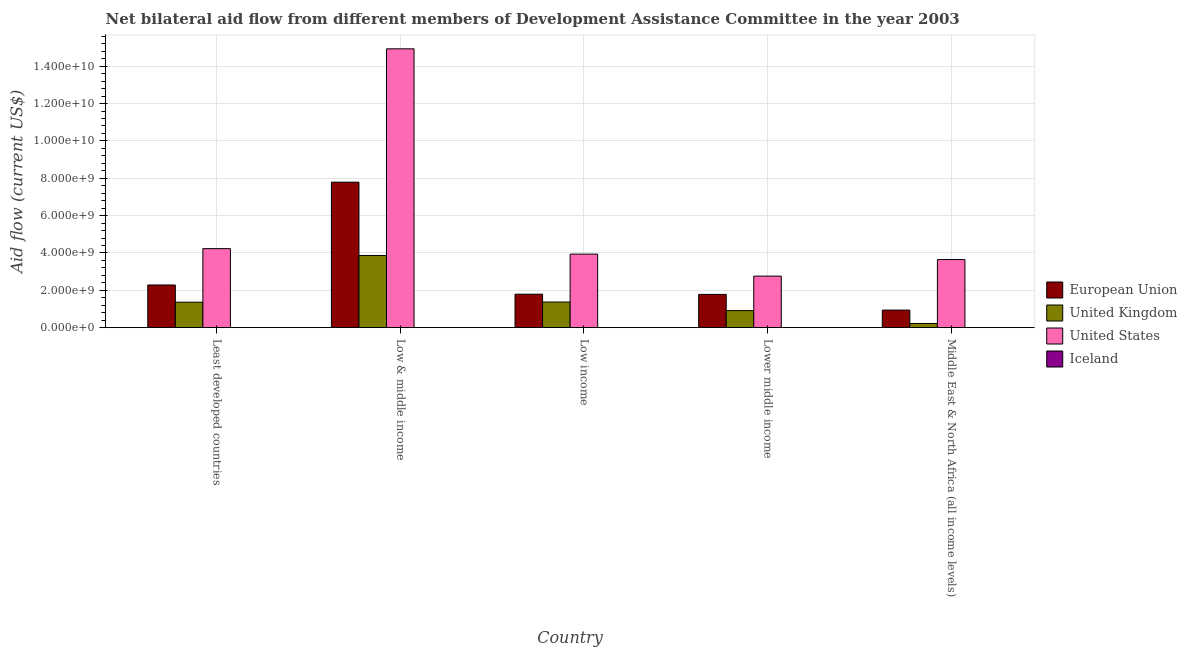How many bars are there on the 2nd tick from the left?
Offer a terse response. 4. What is the label of the 1st group of bars from the left?
Provide a succinct answer. Least developed countries. In how many cases, is the number of bars for a given country not equal to the number of legend labels?
Your answer should be very brief. 0. What is the amount of aid given by iceland in Middle East & North Africa (all income levels)?
Provide a succinct answer. 1.02e+06. Across all countries, what is the maximum amount of aid given by us?
Keep it short and to the point. 1.49e+1. Across all countries, what is the minimum amount of aid given by uk?
Your response must be concise. 2.24e+08. In which country was the amount of aid given by iceland maximum?
Keep it short and to the point. Least developed countries. In which country was the amount of aid given by us minimum?
Offer a terse response. Lower middle income. What is the total amount of aid given by eu in the graph?
Make the answer very short. 1.46e+1. What is the difference between the amount of aid given by iceland in Least developed countries and that in Low & middle income?
Your response must be concise. 6.13e+06. What is the difference between the amount of aid given by uk in Low income and the amount of aid given by eu in Least developed countries?
Keep it short and to the point. -9.13e+08. What is the average amount of aid given by us per country?
Make the answer very short. 5.90e+09. What is the difference between the amount of aid given by us and amount of aid given by uk in Low & middle income?
Offer a terse response. 1.11e+1. In how many countries, is the amount of aid given by iceland greater than 12000000000 US$?
Your answer should be compact. 0. What is the ratio of the amount of aid given by eu in Least developed countries to that in Low income?
Offer a very short reply. 1.28. What is the difference between the highest and the second highest amount of aid given by us?
Offer a terse response. 1.07e+1. What is the difference between the highest and the lowest amount of aid given by uk?
Ensure brevity in your answer.  3.64e+09. Is it the case that in every country, the sum of the amount of aid given by uk and amount of aid given by iceland is greater than the sum of amount of aid given by eu and amount of aid given by us?
Give a very brief answer. No. What does the 1st bar from the left in Least developed countries represents?
Ensure brevity in your answer.  European Union. Are all the bars in the graph horizontal?
Your answer should be compact. No. What is the difference between two consecutive major ticks on the Y-axis?
Give a very brief answer. 2.00e+09. Are the values on the major ticks of Y-axis written in scientific E-notation?
Provide a succinct answer. Yes. Does the graph contain any zero values?
Make the answer very short. No. Does the graph contain grids?
Give a very brief answer. Yes. Where does the legend appear in the graph?
Provide a short and direct response. Center right. What is the title of the graph?
Provide a succinct answer. Net bilateral aid flow from different members of Development Assistance Committee in the year 2003. Does "Insurance services" appear as one of the legend labels in the graph?
Make the answer very short. No. What is the label or title of the Y-axis?
Offer a terse response. Aid flow (current US$). What is the Aid flow (current US$) in European Union in Least developed countries?
Offer a terse response. 2.29e+09. What is the Aid flow (current US$) in United Kingdom in Least developed countries?
Your answer should be compact. 1.36e+09. What is the Aid flow (current US$) in United States in Least developed countries?
Your answer should be compact. 4.23e+09. What is the Aid flow (current US$) in Iceland in Least developed countries?
Ensure brevity in your answer.  6.19e+06. What is the Aid flow (current US$) in European Union in Low & middle income?
Keep it short and to the point. 7.79e+09. What is the Aid flow (current US$) in United Kingdom in Low & middle income?
Offer a terse response. 3.87e+09. What is the Aid flow (current US$) of United States in Low & middle income?
Ensure brevity in your answer.  1.49e+1. What is the Aid flow (current US$) in Iceland in Low & middle income?
Make the answer very short. 6.00e+04. What is the Aid flow (current US$) in European Union in Low income?
Your response must be concise. 1.79e+09. What is the Aid flow (current US$) in United Kingdom in Low income?
Offer a very short reply. 1.37e+09. What is the Aid flow (current US$) in United States in Low income?
Make the answer very short. 3.94e+09. What is the Aid flow (current US$) in Iceland in Low income?
Offer a very short reply. 1.19e+06. What is the Aid flow (current US$) in European Union in Lower middle income?
Your response must be concise. 1.78e+09. What is the Aid flow (current US$) in United Kingdom in Lower middle income?
Offer a very short reply. 9.13e+08. What is the Aid flow (current US$) of United States in Lower middle income?
Give a very brief answer. 2.76e+09. What is the Aid flow (current US$) in Iceland in Lower middle income?
Provide a short and direct response. 1.96e+06. What is the Aid flow (current US$) in European Union in Middle East & North Africa (all income levels)?
Make the answer very short. 9.40e+08. What is the Aid flow (current US$) of United Kingdom in Middle East & North Africa (all income levels)?
Offer a very short reply. 2.24e+08. What is the Aid flow (current US$) in United States in Middle East & North Africa (all income levels)?
Offer a terse response. 3.65e+09. What is the Aid flow (current US$) in Iceland in Middle East & North Africa (all income levels)?
Offer a very short reply. 1.02e+06. Across all countries, what is the maximum Aid flow (current US$) in European Union?
Offer a terse response. 7.79e+09. Across all countries, what is the maximum Aid flow (current US$) of United Kingdom?
Provide a short and direct response. 3.87e+09. Across all countries, what is the maximum Aid flow (current US$) of United States?
Your answer should be compact. 1.49e+1. Across all countries, what is the maximum Aid flow (current US$) in Iceland?
Your answer should be compact. 6.19e+06. Across all countries, what is the minimum Aid flow (current US$) of European Union?
Ensure brevity in your answer.  9.40e+08. Across all countries, what is the minimum Aid flow (current US$) of United Kingdom?
Ensure brevity in your answer.  2.24e+08. Across all countries, what is the minimum Aid flow (current US$) of United States?
Provide a succinct answer. 2.76e+09. What is the total Aid flow (current US$) in European Union in the graph?
Make the answer very short. 1.46e+1. What is the total Aid flow (current US$) in United Kingdom in the graph?
Provide a short and direct response. 7.74e+09. What is the total Aid flow (current US$) in United States in the graph?
Your response must be concise. 2.95e+1. What is the total Aid flow (current US$) of Iceland in the graph?
Your response must be concise. 1.04e+07. What is the difference between the Aid flow (current US$) in European Union in Least developed countries and that in Low & middle income?
Offer a very short reply. -5.50e+09. What is the difference between the Aid flow (current US$) of United Kingdom in Least developed countries and that in Low & middle income?
Your answer should be compact. -2.50e+09. What is the difference between the Aid flow (current US$) in United States in Least developed countries and that in Low & middle income?
Provide a short and direct response. -1.07e+1. What is the difference between the Aid flow (current US$) in Iceland in Least developed countries and that in Low & middle income?
Provide a short and direct response. 6.13e+06. What is the difference between the Aid flow (current US$) in European Union in Least developed countries and that in Low income?
Your answer should be very brief. 4.94e+08. What is the difference between the Aid flow (current US$) of United Kingdom in Least developed countries and that in Low income?
Your answer should be compact. -8.84e+06. What is the difference between the Aid flow (current US$) in United States in Least developed countries and that in Low income?
Offer a terse response. 2.94e+08. What is the difference between the Aid flow (current US$) in Iceland in Least developed countries and that in Low income?
Provide a succinct answer. 5.00e+06. What is the difference between the Aid flow (current US$) of European Union in Least developed countries and that in Lower middle income?
Make the answer very short. 5.04e+08. What is the difference between the Aid flow (current US$) in United Kingdom in Least developed countries and that in Lower middle income?
Provide a succinct answer. 4.51e+08. What is the difference between the Aid flow (current US$) of United States in Least developed countries and that in Lower middle income?
Make the answer very short. 1.47e+09. What is the difference between the Aid flow (current US$) of Iceland in Least developed countries and that in Lower middle income?
Offer a very short reply. 4.23e+06. What is the difference between the Aid flow (current US$) in European Union in Least developed countries and that in Middle East & North Africa (all income levels)?
Your answer should be compact. 1.35e+09. What is the difference between the Aid flow (current US$) of United Kingdom in Least developed countries and that in Middle East & North Africa (all income levels)?
Provide a succinct answer. 1.14e+09. What is the difference between the Aid flow (current US$) in United States in Least developed countries and that in Middle East & North Africa (all income levels)?
Make the answer very short. 5.85e+08. What is the difference between the Aid flow (current US$) of Iceland in Least developed countries and that in Middle East & North Africa (all income levels)?
Make the answer very short. 5.17e+06. What is the difference between the Aid flow (current US$) of European Union in Low & middle income and that in Low income?
Your answer should be very brief. 6.00e+09. What is the difference between the Aid flow (current US$) of United Kingdom in Low & middle income and that in Low income?
Provide a succinct answer. 2.49e+09. What is the difference between the Aid flow (current US$) in United States in Low & middle income and that in Low income?
Provide a short and direct response. 1.10e+1. What is the difference between the Aid flow (current US$) of Iceland in Low & middle income and that in Low income?
Offer a terse response. -1.13e+06. What is the difference between the Aid flow (current US$) in European Union in Low & middle income and that in Lower middle income?
Your answer should be very brief. 6.01e+09. What is the difference between the Aid flow (current US$) in United Kingdom in Low & middle income and that in Lower middle income?
Provide a succinct answer. 2.95e+09. What is the difference between the Aid flow (current US$) in United States in Low & middle income and that in Lower middle income?
Provide a succinct answer. 1.22e+1. What is the difference between the Aid flow (current US$) in Iceland in Low & middle income and that in Lower middle income?
Provide a succinct answer. -1.90e+06. What is the difference between the Aid flow (current US$) of European Union in Low & middle income and that in Middle East & North Africa (all income levels)?
Give a very brief answer. 6.85e+09. What is the difference between the Aid flow (current US$) of United Kingdom in Low & middle income and that in Middle East & North Africa (all income levels)?
Ensure brevity in your answer.  3.64e+09. What is the difference between the Aid flow (current US$) in United States in Low & middle income and that in Middle East & North Africa (all income levels)?
Your response must be concise. 1.13e+1. What is the difference between the Aid flow (current US$) of Iceland in Low & middle income and that in Middle East & North Africa (all income levels)?
Ensure brevity in your answer.  -9.60e+05. What is the difference between the Aid flow (current US$) of European Union in Low income and that in Lower middle income?
Make the answer very short. 1.04e+07. What is the difference between the Aid flow (current US$) in United Kingdom in Low income and that in Lower middle income?
Your answer should be very brief. 4.60e+08. What is the difference between the Aid flow (current US$) of United States in Low income and that in Lower middle income?
Ensure brevity in your answer.  1.18e+09. What is the difference between the Aid flow (current US$) of Iceland in Low income and that in Lower middle income?
Offer a very short reply. -7.70e+05. What is the difference between the Aid flow (current US$) of European Union in Low income and that in Middle East & North Africa (all income levels)?
Give a very brief answer. 8.52e+08. What is the difference between the Aid flow (current US$) in United Kingdom in Low income and that in Middle East & North Africa (all income levels)?
Provide a succinct answer. 1.15e+09. What is the difference between the Aid flow (current US$) in United States in Low income and that in Middle East & North Africa (all income levels)?
Make the answer very short. 2.91e+08. What is the difference between the Aid flow (current US$) in European Union in Lower middle income and that in Middle East & North Africa (all income levels)?
Provide a succinct answer. 8.42e+08. What is the difference between the Aid flow (current US$) in United Kingdom in Lower middle income and that in Middle East & North Africa (all income levels)?
Provide a short and direct response. 6.89e+08. What is the difference between the Aid flow (current US$) in United States in Lower middle income and that in Middle East & North Africa (all income levels)?
Give a very brief answer. -8.86e+08. What is the difference between the Aid flow (current US$) of Iceland in Lower middle income and that in Middle East & North Africa (all income levels)?
Make the answer very short. 9.40e+05. What is the difference between the Aid flow (current US$) in European Union in Least developed countries and the Aid flow (current US$) in United Kingdom in Low & middle income?
Make the answer very short. -1.58e+09. What is the difference between the Aid flow (current US$) of European Union in Least developed countries and the Aid flow (current US$) of United States in Low & middle income?
Offer a terse response. -1.26e+1. What is the difference between the Aid flow (current US$) in European Union in Least developed countries and the Aid flow (current US$) in Iceland in Low & middle income?
Provide a short and direct response. 2.29e+09. What is the difference between the Aid flow (current US$) in United Kingdom in Least developed countries and the Aid flow (current US$) in United States in Low & middle income?
Provide a short and direct response. -1.36e+1. What is the difference between the Aid flow (current US$) in United Kingdom in Least developed countries and the Aid flow (current US$) in Iceland in Low & middle income?
Offer a terse response. 1.36e+09. What is the difference between the Aid flow (current US$) of United States in Least developed countries and the Aid flow (current US$) of Iceland in Low & middle income?
Your answer should be very brief. 4.23e+09. What is the difference between the Aid flow (current US$) in European Union in Least developed countries and the Aid flow (current US$) in United Kingdom in Low income?
Give a very brief answer. 9.13e+08. What is the difference between the Aid flow (current US$) in European Union in Least developed countries and the Aid flow (current US$) in United States in Low income?
Your answer should be very brief. -1.65e+09. What is the difference between the Aid flow (current US$) of European Union in Least developed countries and the Aid flow (current US$) of Iceland in Low income?
Your answer should be compact. 2.28e+09. What is the difference between the Aid flow (current US$) of United Kingdom in Least developed countries and the Aid flow (current US$) of United States in Low income?
Offer a terse response. -2.57e+09. What is the difference between the Aid flow (current US$) in United Kingdom in Least developed countries and the Aid flow (current US$) in Iceland in Low income?
Offer a terse response. 1.36e+09. What is the difference between the Aid flow (current US$) in United States in Least developed countries and the Aid flow (current US$) in Iceland in Low income?
Offer a terse response. 4.23e+09. What is the difference between the Aid flow (current US$) of European Union in Least developed countries and the Aid flow (current US$) of United Kingdom in Lower middle income?
Your answer should be very brief. 1.37e+09. What is the difference between the Aid flow (current US$) of European Union in Least developed countries and the Aid flow (current US$) of United States in Lower middle income?
Keep it short and to the point. -4.74e+08. What is the difference between the Aid flow (current US$) of European Union in Least developed countries and the Aid flow (current US$) of Iceland in Lower middle income?
Provide a short and direct response. 2.28e+09. What is the difference between the Aid flow (current US$) of United Kingdom in Least developed countries and the Aid flow (current US$) of United States in Lower middle income?
Your answer should be compact. -1.40e+09. What is the difference between the Aid flow (current US$) of United Kingdom in Least developed countries and the Aid flow (current US$) of Iceland in Lower middle income?
Provide a succinct answer. 1.36e+09. What is the difference between the Aid flow (current US$) of United States in Least developed countries and the Aid flow (current US$) of Iceland in Lower middle income?
Offer a very short reply. 4.23e+09. What is the difference between the Aid flow (current US$) in European Union in Least developed countries and the Aid flow (current US$) in United Kingdom in Middle East & North Africa (all income levels)?
Your response must be concise. 2.06e+09. What is the difference between the Aid flow (current US$) in European Union in Least developed countries and the Aid flow (current US$) in United States in Middle East & North Africa (all income levels)?
Your answer should be compact. -1.36e+09. What is the difference between the Aid flow (current US$) of European Union in Least developed countries and the Aid flow (current US$) of Iceland in Middle East & North Africa (all income levels)?
Keep it short and to the point. 2.28e+09. What is the difference between the Aid flow (current US$) in United Kingdom in Least developed countries and the Aid flow (current US$) in United States in Middle East & North Africa (all income levels)?
Your answer should be very brief. -2.28e+09. What is the difference between the Aid flow (current US$) in United Kingdom in Least developed countries and the Aid flow (current US$) in Iceland in Middle East & North Africa (all income levels)?
Your response must be concise. 1.36e+09. What is the difference between the Aid flow (current US$) in United States in Least developed countries and the Aid flow (current US$) in Iceland in Middle East & North Africa (all income levels)?
Make the answer very short. 4.23e+09. What is the difference between the Aid flow (current US$) in European Union in Low & middle income and the Aid flow (current US$) in United Kingdom in Low income?
Provide a succinct answer. 6.42e+09. What is the difference between the Aid flow (current US$) of European Union in Low & middle income and the Aid flow (current US$) of United States in Low income?
Your answer should be compact. 3.85e+09. What is the difference between the Aid flow (current US$) of European Union in Low & middle income and the Aid flow (current US$) of Iceland in Low income?
Make the answer very short. 7.79e+09. What is the difference between the Aid flow (current US$) in United Kingdom in Low & middle income and the Aid flow (current US$) in United States in Low income?
Offer a terse response. -7.21e+07. What is the difference between the Aid flow (current US$) in United Kingdom in Low & middle income and the Aid flow (current US$) in Iceland in Low income?
Your answer should be very brief. 3.86e+09. What is the difference between the Aid flow (current US$) of United States in Low & middle income and the Aid flow (current US$) of Iceland in Low income?
Offer a very short reply. 1.49e+1. What is the difference between the Aid flow (current US$) of European Union in Low & middle income and the Aid flow (current US$) of United Kingdom in Lower middle income?
Offer a very short reply. 6.88e+09. What is the difference between the Aid flow (current US$) in European Union in Low & middle income and the Aid flow (current US$) in United States in Lower middle income?
Give a very brief answer. 5.03e+09. What is the difference between the Aid flow (current US$) of European Union in Low & middle income and the Aid flow (current US$) of Iceland in Lower middle income?
Offer a terse response. 7.79e+09. What is the difference between the Aid flow (current US$) of United Kingdom in Low & middle income and the Aid flow (current US$) of United States in Lower middle income?
Provide a succinct answer. 1.11e+09. What is the difference between the Aid flow (current US$) in United Kingdom in Low & middle income and the Aid flow (current US$) in Iceland in Lower middle income?
Your answer should be very brief. 3.86e+09. What is the difference between the Aid flow (current US$) of United States in Low & middle income and the Aid flow (current US$) of Iceland in Lower middle income?
Give a very brief answer. 1.49e+1. What is the difference between the Aid flow (current US$) in European Union in Low & middle income and the Aid flow (current US$) in United Kingdom in Middle East & North Africa (all income levels)?
Offer a very short reply. 7.57e+09. What is the difference between the Aid flow (current US$) of European Union in Low & middle income and the Aid flow (current US$) of United States in Middle East & North Africa (all income levels)?
Your answer should be very brief. 4.14e+09. What is the difference between the Aid flow (current US$) of European Union in Low & middle income and the Aid flow (current US$) of Iceland in Middle East & North Africa (all income levels)?
Keep it short and to the point. 7.79e+09. What is the difference between the Aid flow (current US$) of United Kingdom in Low & middle income and the Aid flow (current US$) of United States in Middle East & North Africa (all income levels)?
Offer a terse response. 2.19e+08. What is the difference between the Aid flow (current US$) of United Kingdom in Low & middle income and the Aid flow (current US$) of Iceland in Middle East & North Africa (all income levels)?
Offer a very short reply. 3.86e+09. What is the difference between the Aid flow (current US$) of United States in Low & middle income and the Aid flow (current US$) of Iceland in Middle East & North Africa (all income levels)?
Give a very brief answer. 1.49e+1. What is the difference between the Aid flow (current US$) in European Union in Low income and the Aid flow (current US$) in United Kingdom in Lower middle income?
Offer a very short reply. 8.79e+08. What is the difference between the Aid flow (current US$) in European Union in Low income and the Aid flow (current US$) in United States in Lower middle income?
Keep it short and to the point. -9.68e+08. What is the difference between the Aid flow (current US$) of European Union in Low income and the Aid flow (current US$) of Iceland in Lower middle income?
Keep it short and to the point. 1.79e+09. What is the difference between the Aid flow (current US$) in United Kingdom in Low income and the Aid flow (current US$) in United States in Lower middle income?
Give a very brief answer. -1.39e+09. What is the difference between the Aid flow (current US$) in United Kingdom in Low income and the Aid flow (current US$) in Iceland in Lower middle income?
Offer a very short reply. 1.37e+09. What is the difference between the Aid flow (current US$) of United States in Low income and the Aid flow (current US$) of Iceland in Lower middle income?
Your response must be concise. 3.94e+09. What is the difference between the Aid flow (current US$) of European Union in Low income and the Aid flow (current US$) of United Kingdom in Middle East & North Africa (all income levels)?
Provide a short and direct response. 1.57e+09. What is the difference between the Aid flow (current US$) in European Union in Low income and the Aid flow (current US$) in United States in Middle East & North Africa (all income levels)?
Your answer should be compact. -1.85e+09. What is the difference between the Aid flow (current US$) of European Union in Low income and the Aid flow (current US$) of Iceland in Middle East & North Africa (all income levels)?
Ensure brevity in your answer.  1.79e+09. What is the difference between the Aid flow (current US$) in United Kingdom in Low income and the Aid flow (current US$) in United States in Middle East & North Africa (all income levels)?
Provide a succinct answer. -2.27e+09. What is the difference between the Aid flow (current US$) of United Kingdom in Low income and the Aid flow (current US$) of Iceland in Middle East & North Africa (all income levels)?
Your response must be concise. 1.37e+09. What is the difference between the Aid flow (current US$) in United States in Low income and the Aid flow (current US$) in Iceland in Middle East & North Africa (all income levels)?
Offer a terse response. 3.94e+09. What is the difference between the Aid flow (current US$) of European Union in Lower middle income and the Aid flow (current US$) of United Kingdom in Middle East & North Africa (all income levels)?
Offer a very short reply. 1.56e+09. What is the difference between the Aid flow (current US$) of European Union in Lower middle income and the Aid flow (current US$) of United States in Middle East & North Africa (all income levels)?
Your answer should be very brief. -1.86e+09. What is the difference between the Aid flow (current US$) of European Union in Lower middle income and the Aid flow (current US$) of Iceland in Middle East & North Africa (all income levels)?
Your answer should be very brief. 1.78e+09. What is the difference between the Aid flow (current US$) of United Kingdom in Lower middle income and the Aid flow (current US$) of United States in Middle East & North Africa (all income levels)?
Your answer should be very brief. -2.73e+09. What is the difference between the Aid flow (current US$) of United Kingdom in Lower middle income and the Aid flow (current US$) of Iceland in Middle East & North Africa (all income levels)?
Offer a very short reply. 9.12e+08. What is the difference between the Aid flow (current US$) of United States in Lower middle income and the Aid flow (current US$) of Iceland in Middle East & North Africa (all income levels)?
Your response must be concise. 2.76e+09. What is the average Aid flow (current US$) in European Union per country?
Your response must be concise. 2.92e+09. What is the average Aid flow (current US$) in United Kingdom per country?
Make the answer very short. 1.55e+09. What is the average Aid flow (current US$) of United States per country?
Provide a short and direct response. 5.90e+09. What is the average Aid flow (current US$) in Iceland per country?
Ensure brevity in your answer.  2.08e+06. What is the difference between the Aid flow (current US$) in European Union and Aid flow (current US$) in United Kingdom in Least developed countries?
Your answer should be very brief. 9.22e+08. What is the difference between the Aid flow (current US$) in European Union and Aid flow (current US$) in United States in Least developed countries?
Provide a succinct answer. -1.95e+09. What is the difference between the Aid flow (current US$) of European Union and Aid flow (current US$) of Iceland in Least developed countries?
Give a very brief answer. 2.28e+09. What is the difference between the Aid flow (current US$) of United Kingdom and Aid flow (current US$) of United States in Least developed countries?
Your answer should be very brief. -2.87e+09. What is the difference between the Aid flow (current US$) of United Kingdom and Aid flow (current US$) of Iceland in Least developed countries?
Ensure brevity in your answer.  1.36e+09. What is the difference between the Aid flow (current US$) of United States and Aid flow (current US$) of Iceland in Least developed countries?
Provide a short and direct response. 4.23e+09. What is the difference between the Aid flow (current US$) of European Union and Aid flow (current US$) of United Kingdom in Low & middle income?
Give a very brief answer. 3.93e+09. What is the difference between the Aid flow (current US$) of European Union and Aid flow (current US$) of United States in Low & middle income?
Provide a short and direct response. -7.14e+09. What is the difference between the Aid flow (current US$) of European Union and Aid flow (current US$) of Iceland in Low & middle income?
Ensure brevity in your answer.  7.79e+09. What is the difference between the Aid flow (current US$) in United Kingdom and Aid flow (current US$) in United States in Low & middle income?
Your answer should be very brief. -1.11e+1. What is the difference between the Aid flow (current US$) of United Kingdom and Aid flow (current US$) of Iceland in Low & middle income?
Give a very brief answer. 3.87e+09. What is the difference between the Aid flow (current US$) in United States and Aid flow (current US$) in Iceland in Low & middle income?
Your response must be concise. 1.49e+1. What is the difference between the Aid flow (current US$) in European Union and Aid flow (current US$) in United Kingdom in Low income?
Your answer should be compact. 4.19e+08. What is the difference between the Aid flow (current US$) in European Union and Aid flow (current US$) in United States in Low income?
Offer a very short reply. -2.15e+09. What is the difference between the Aid flow (current US$) in European Union and Aid flow (current US$) in Iceland in Low income?
Offer a terse response. 1.79e+09. What is the difference between the Aid flow (current US$) in United Kingdom and Aid flow (current US$) in United States in Low income?
Keep it short and to the point. -2.56e+09. What is the difference between the Aid flow (current US$) in United Kingdom and Aid flow (current US$) in Iceland in Low income?
Provide a short and direct response. 1.37e+09. What is the difference between the Aid flow (current US$) of United States and Aid flow (current US$) of Iceland in Low income?
Offer a very short reply. 3.94e+09. What is the difference between the Aid flow (current US$) in European Union and Aid flow (current US$) in United Kingdom in Lower middle income?
Provide a short and direct response. 8.69e+08. What is the difference between the Aid flow (current US$) of European Union and Aid flow (current US$) of United States in Lower middle income?
Ensure brevity in your answer.  -9.79e+08. What is the difference between the Aid flow (current US$) of European Union and Aid flow (current US$) of Iceland in Lower middle income?
Offer a terse response. 1.78e+09. What is the difference between the Aid flow (current US$) in United Kingdom and Aid flow (current US$) in United States in Lower middle income?
Make the answer very short. -1.85e+09. What is the difference between the Aid flow (current US$) in United Kingdom and Aid flow (current US$) in Iceland in Lower middle income?
Give a very brief answer. 9.11e+08. What is the difference between the Aid flow (current US$) in United States and Aid flow (current US$) in Iceland in Lower middle income?
Give a very brief answer. 2.76e+09. What is the difference between the Aid flow (current US$) of European Union and Aid flow (current US$) of United Kingdom in Middle East & North Africa (all income levels)?
Your answer should be compact. 7.16e+08. What is the difference between the Aid flow (current US$) of European Union and Aid flow (current US$) of United States in Middle East & North Africa (all income levels)?
Your answer should be very brief. -2.71e+09. What is the difference between the Aid flow (current US$) in European Union and Aid flow (current US$) in Iceland in Middle East & North Africa (all income levels)?
Your answer should be very brief. 9.39e+08. What is the difference between the Aid flow (current US$) in United Kingdom and Aid flow (current US$) in United States in Middle East & North Africa (all income levels)?
Your answer should be very brief. -3.42e+09. What is the difference between the Aid flow (current US$) of United Kingdom and Aid flow (current US$) of Iceland in Middle East & North Africa (all income levels)?
Offer a terse response. 2.23e+08. What is the difference between the Aid flow (current US$) in United States and Aid flow (current US$) in Iceland in Middle East & North Africa (all income levels)?
Ensure brevity in your answer.  3.65e+09. What is the ratio of the Aid flow (current US$) of European Union in Least developed countries to that in Low & middle income?
Offer a terse response. 0.29. What is the ratio of the Aid flow (current US$) in United Kingdom in Least developed countries to that in Low & middle income?
Make the answer very short. 0.35. What is the ratio of the Aid flow (current US$) of United States in Least developed countries to that in Low & middle income?
Keep it short and to the point. 0.28. What is the ratio of the Aid flow (current US$) of Iceland in Least developed countries to that in Low & middle income?
Offer a terse response. 103.17. What is the ratio of the Aid flow (current US$) of European Union in Least developed countries to that in Low income?
Make the answer very short. 1.28. What is the ratio of the Aid flow (current US$) of United Kingdom in Least developed countries to that in Low income?
Ensure brevity in your answer.  0.99. What is the ratio of the Aid flow (current US$) of United States in Least developed countries to that in Low income?
Your answer should be very brief. 1.07. What is the ratio of the Aid flow (current US$) in Iceland in Least developed countries to that in Low income?
Provide a succinct answer. 5.2. What is the ratio of the Aid flow (current US$) in European Union in Least developed countries to that in Lower middle income?
Offer a very short reply. 1.28. What is the ratio of the Aid flow (current US$) in United Kingdom in Least developed countries to that in Lower middle income?
Make the answer very short. 1.49. What is the ratio of the Aid flow (current US$) of United States in Least developed countries to that in Lower middle income?
Offer a terse response. 1.53. What is the ratio of the Aid flow (current US$) of Iceland in Least developed countries to that in Lower middle income?
Provide a short and direct response. 3.16. What is the ratio of the Aid flow (current US$) in European Union in Least developed countries to that in Middle East & North Africa (all income levels)?
Give a very brief answer. 2.43. What is the ratio of the Aid flow (current US$) of United Kingdom in Least developed countries to that in Middle East & North Africa (all income levels)?
Make the answer very short. 6.09. What is the ratio of the Aid flow (current US$) in United States in Least developed countries to that in Middle East & North Africa (all income levels)?
Your response must be concise. 1.16. What is the ratio of the Aid flow (current US$) of Iceland in Least developed countries to that in Middle East & North Africa (all income levels)?
Offer a very short reply. 6.07. What is the ratio of the Aid flow (current US$) in European Union in Low & middle income to that in Low income?
Make the answer very short. 4.35. What is the ratio of the Aid flow (current US$) in United Kingdom in Low & middle income to that in Low income?
Offer a very short reply. 2.82. What is the ratio of the Aid flow (current US$) in United States in Low & middle income to that in Low income?
Offer a very short reply. 3.79. What is the ratio of the Aid flow (current US$) in Iceland in Low & middle income to that in Low income?
Your answer should be compact. 0.05. What is the ratio of the Aid flow (current US$) in European Union in Low & middle income to that in Lower middle income?
Make the answer very short. 4.37. What is the ratio of the Aid flow (current US$) in United Kingdom in Low & middle income to that in Lower middle income?
Your answer should be very brief. 4.24. What is the ratio of the Aid flow (current US$) in United States in Low & middle income to that in Lower middle income?
Your answer should be very brief. 5.41. What is the ratio of the Aid flow (current US$) of Iceland in Low & middle income to that in Lower middle income?
Offer a terse response. 0.03. What is the ratio of the Aid flow (current US$) in European Union in Low & middle income to that in Middle East & North Africa (all income levels)?
Provide a short and direct response. 8.29. What is the ratio of the Aid flow (current US$) in United Kingdom in Low & middle income to that in Middle East & North Africa (all income levels)?
Your answer should be compact. 17.26. What is the ratio of the Aid flow (current US$) in United States in Low & middle income to that in Middle East & North Africa (all income levels)?
Offer a very short reply. 4.09. What is the ratio of the Aid flow (current US$) in Iceland in Low & middle income to that in Middle East & North Africa (all income levels)?
Ensure brevity in your answer.  0.06. What is the ratio of the Aid flow (current US$) of European Union in Low income to that in Lower middle income?
Your answer should be compact. 1.01. What is the ratio of the Aid flow (current US$) of United Kingdom in Low income to that in Lower middle income?
Make the answer very short. 1.5. What is the ratio of the Aid flow (current US$) of United States in Low income to that in Lower middle income?
Your answer should be very brief. 1.43. What is the ratio of the Aid flow (current US$) in Iceland in Low income to that in Lower middle income?
Your answer should be compact. 0.61. What is the ratio of the Aid flow (current US$) of European Union in Low income to that in Middle East & North Africa (all income levels)?
Provide a short and direct response. 1.91. What is the ratio of the Aid flow (current US$) in United Kingdom in Low income to that in Middle East & North Africa (all income levels)?
Provide a succinct answer. 6.13. What is the ratio of the Aid flow (current US$) in United States in Low income to that in Middle East & North Africa (all income levels)?
Your response must be concise. 1.08. What is the ratio of the Aid flow (current US$) of Iceland in Low income to that in Middle East & North Africa (all income levels)?
Make the answer very short. 1.17. What is the ratio of the Aid flow (current US$) in European Union in Lower middle income to that in Middle East & North Africa (all income levels)?
Offer a terse response. 1.9. What is the ratio of the Aid flow (current US$) of United Kingdom in Lower middle income to that in Middle East & North Africa (all income levels)?
Offer a very short reply. 4.07. What is the ratio of the Aid flow (current US$) of United States in Lower middle income to that in Middle East & North Africa (all income levels)?
Make the answer very short. 0.76. What is the ratio of the Aid flow (current US$) of Iceland in Lower middle income to that in Middle East & North Africa (all income levels)?
Ensure brevity in your answer.  1.92. What is the difference between the highest and the second highest Aid flow (current US$) of European Union?
Your answer should be very brief. 5.50e+09. What is the difference between the highest and the second highest Aid flow (current US$) of United Kingdom?
Keep it short and to the point. 2.49e+09. What is the difference between the highest and the second highest Aid flow (current US$) of United States?
Give a very brief answer. 1.07e+1. What is the difference between the highest and the second highest Aid flow (current US$) of Iceland?
Offer a terse response. 4.23e+06. What is the difference between the highest and the lowest Aid flow (current US$) of European Union?
Give a very brief answer. 6.85e+09. What is the difference between the highest and the lowest Aid flow (current US$) in United Kingdom?
Your answer should be very brief. 3.64e+09. What is the difference between the highest and the lowest Aid flow (current US$) in United States?
Offer a terse response. 1.22e+1. What is the difference between the highest and the lowest Aid flow (current US$) in Iceland?
Keep it short and to the point. 6.13e+06. 